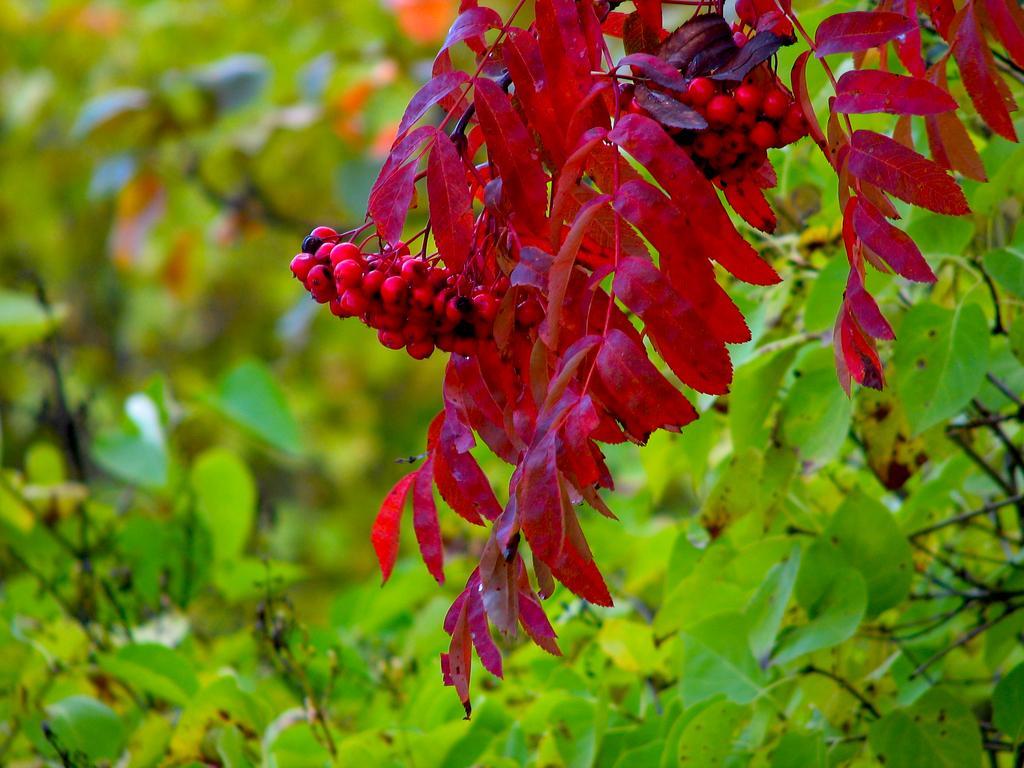How would you summarize this image in a sentence or two? In this image we can see trees. 